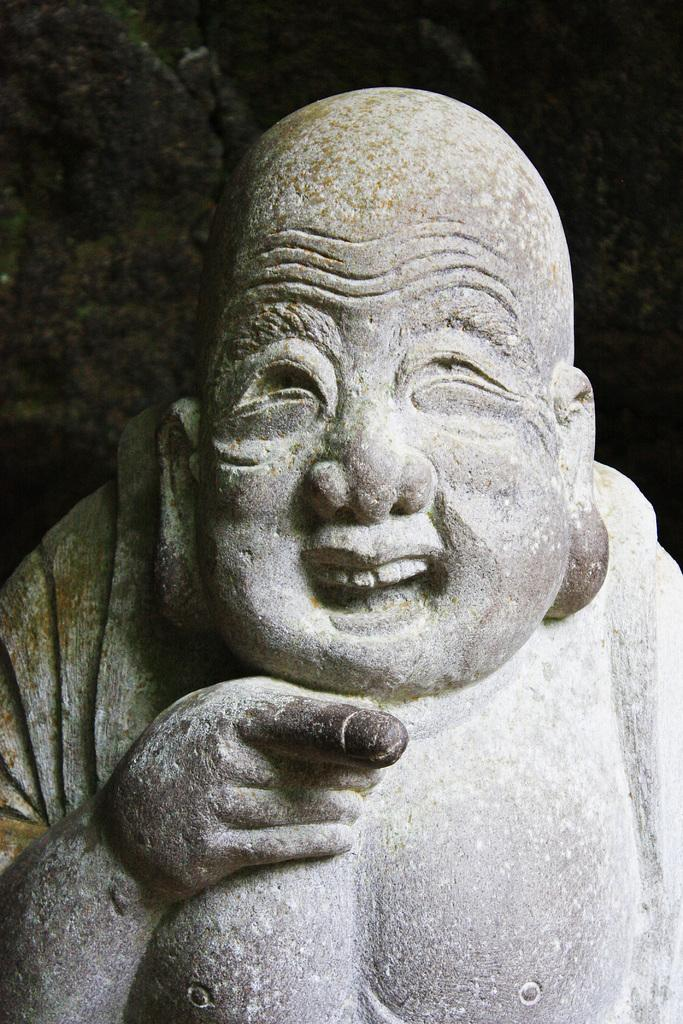What is the main subject in the image? There is a statue in the image. What material is the statue made of? The statue is made up of rock. How many tickets are attached to the statue in the image? There are no tickets attached to the statue in the image. What type of muscle can be seen on the statue in the image? There is no muscle present on the statue in the image, as it is made of rock and not a living organism. 